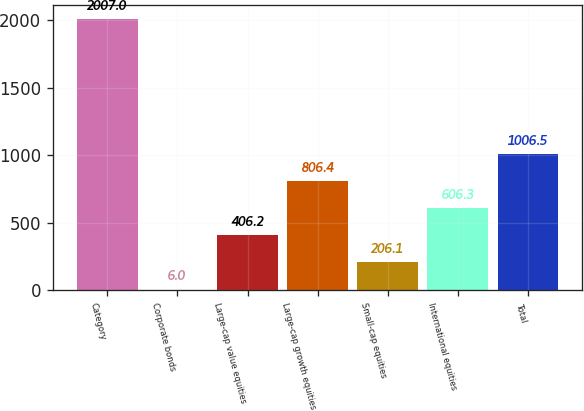Convert chart. <chart><loc_0><loc_0><loc_500><loc_500><bar_chart><fcel>Category<fcel>Corporate bonds<fcel>Large-cap value equities<fcel>Large-cap growth equities<fcel>Small-cap equities<fcel>International equities<fcel>Total<nl><fcel>2007<fcel>6<fcel>406.2<fcel>806.4<fcel>206.1<fcel>606.3<fcel>1006.5<nl></chart> 